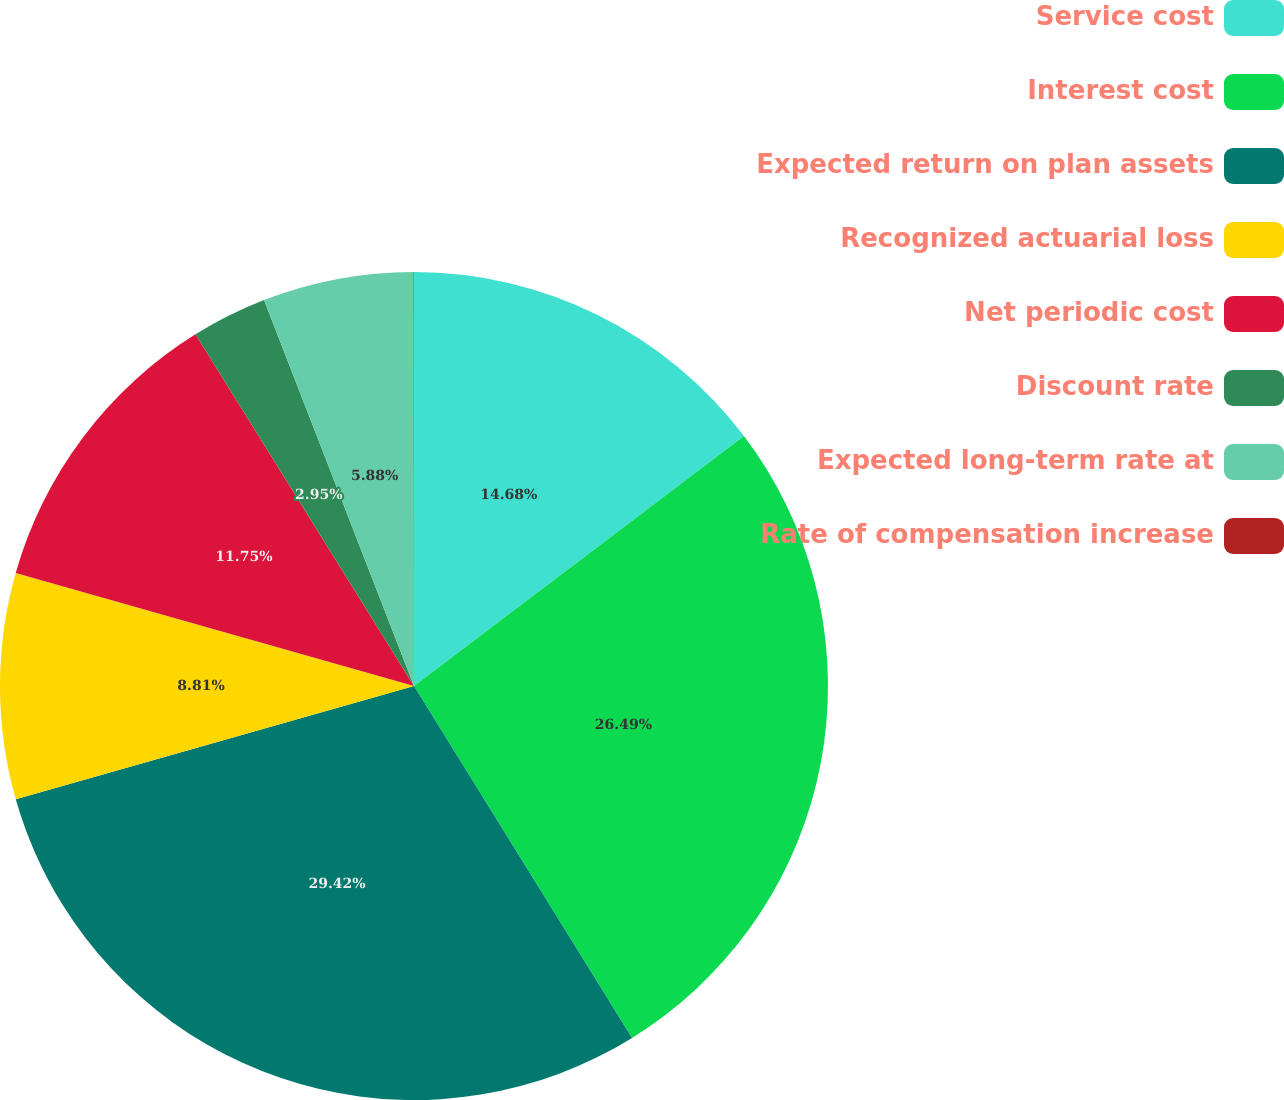<chart> <loc_0><loc_0><loc_500><loc_500><pie_chart><fcel>Service cost<fcel>Interest cost<fcel>Expected return on plan assets<fcel>Recognized actuarial loss<fcel>Net periodic cost<fcel>Discount rate<fcel>Expected long-term rate at<fcel>Rate of compensation increase<nl><fcel>14.68%<fcel>26.49%<fcel>29.42%<fcel>8.81%<fcel>11.75%<fcel>2.95%<fcel>5.88%<fcel>0.02%<nl></chart> 